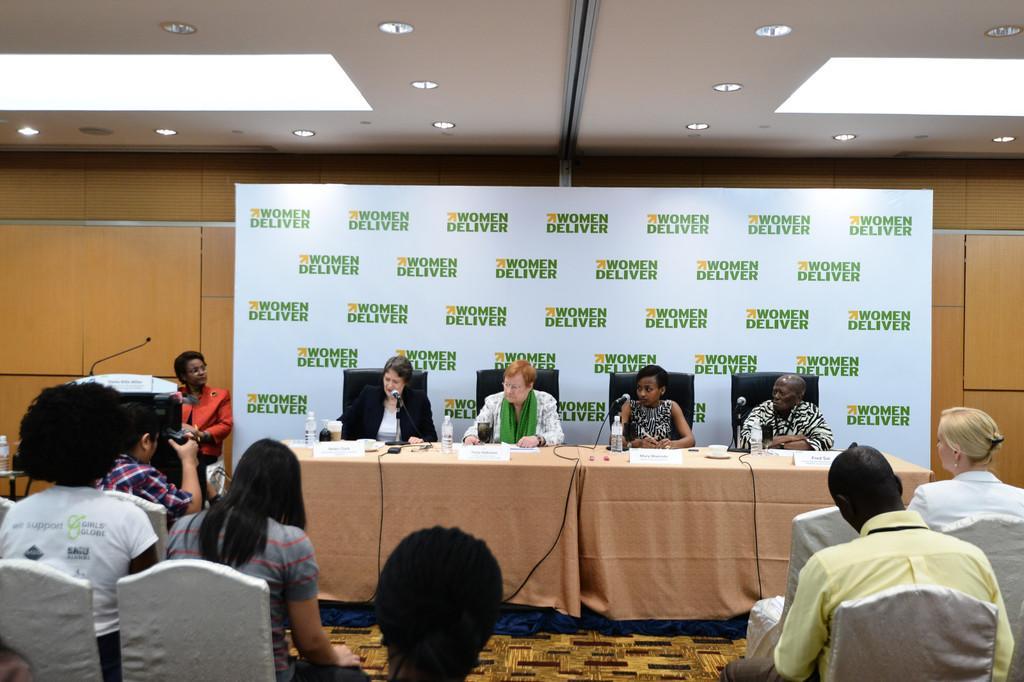In one or two sentences, can you explain what this image depicts? In this image we can see people sitting on chairs. At the bottom of the image there is carpet. In the background of the image there are people sitting on chairs. There is a table on which there is a cloth. There are bottles, mic. In the background of the image there is wooden wall. There is banner with some text on it. At the top of the image there is ceiling with lights. 